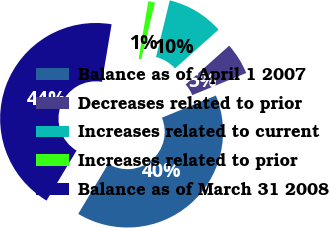Convert chart to OTSL. <chart><loc_0><loc_0><loc_500><loc_500><pie_chart><fcel>Balance as of April 1 2007<fcel>Decreases related to prior<fcel>Increases related to current<fcel>Increases related to prior<fcel>Balance as of March 31 2008<nl><fcel>39.81%<fcel>5.38%<fcel>9.62%<fcel>1.14%<fcel>44.05%<nl></chart> 